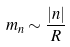<formula> <loc_0><loc_0><loc_500><loc_500>m _ { n } \sim \frac { | n | } { R }</formula> 